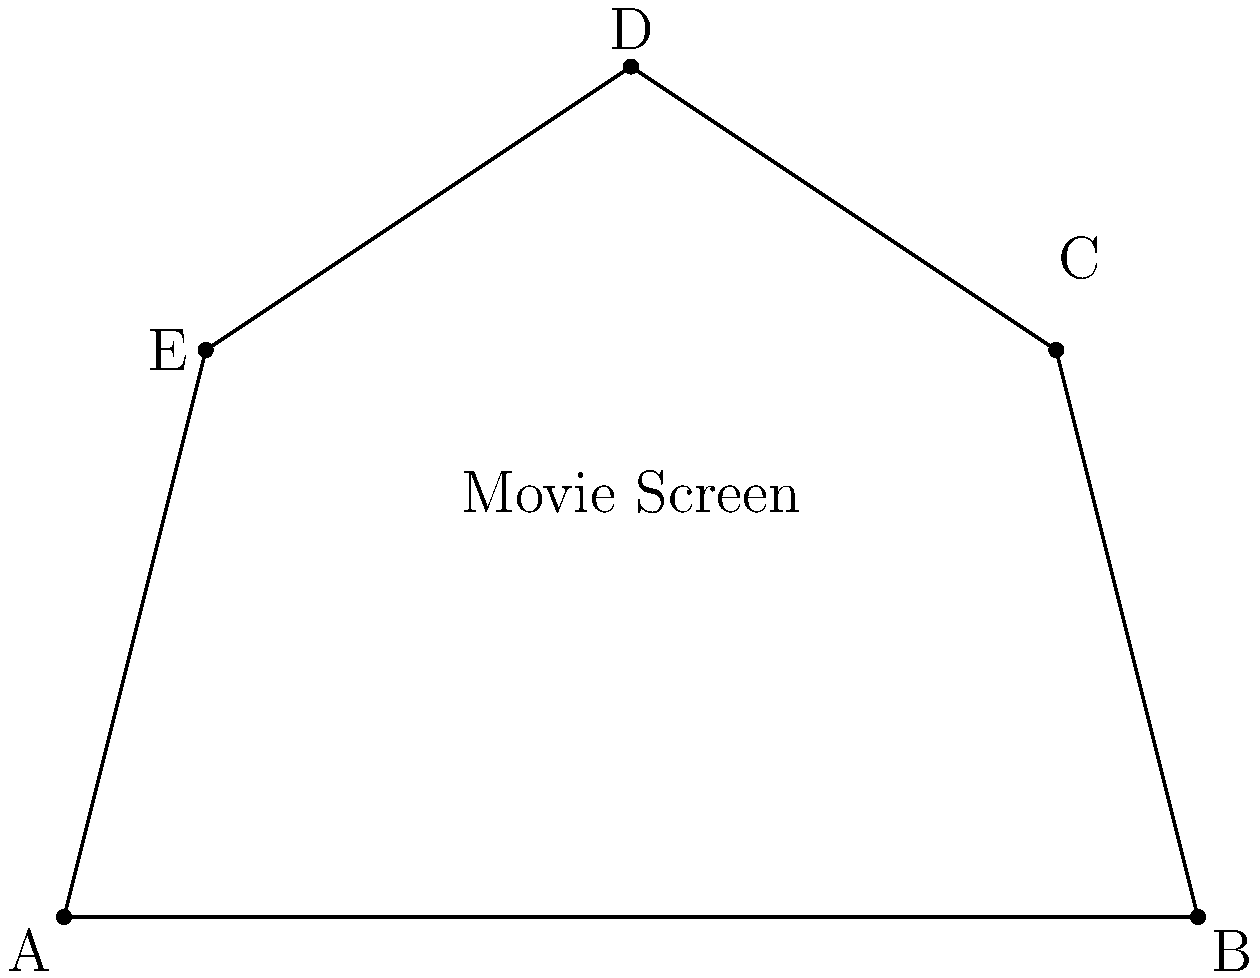In an effort to recreate the ambiance of early 20th-century cinema, you're designing a uniquely shaped movie screen for your vintage film festival. The screen is a pentagon with vertices at A(0,0), B(8,0), C(7,4), D(4,6), and E(1,4). What is the area of this pentagonal movie screen in square units? To find the area of this irregular pentagon, we can use the following steps:

1) Divide the pentagon into three triangles: ABC, ACD, and ADE.

2) Calculate the area of each triangle using the formula:
   Area = $\frac{1}{2}|x_1(y_2 - y_3) + x_2(y_3 - y_1) + x_3(y_1 - y_2)|$

3) For triangle ABC:
   $A_{ABC} = \frac{1}{2}|0(0-4) + 8(4-0) + 7(0-0)| = 16$

4) For triangle ACD:
   $A_{ACD} = \frac{1}{2}|0(4-6) + 7(6-0) + 4(0-4)| = 14$

5) For triangle ADE:
   $A_{ADE} = \frac{1}{2}|0(6-4) + 4(4-0) + 1(0-6)| = 6$

6) Sum up the areas of all triangles:
   Total Area = $A_{ABC} + A_{ACD} + A_{ADE} = 16 + 14 + 6 = 36$

Therefore, the area of the pentagonal movie screen is 36 square units.
Answer: 36 square units 